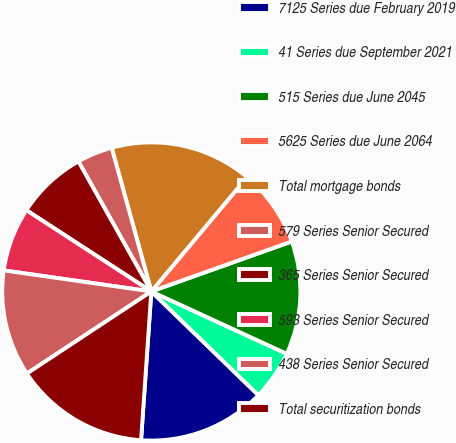Convert chart. <chart><loc_0><loc_0><loc_500><loc_500><pie_chart><fcel>7125 Series due February 2019<fcel>41 Series due September 2021<fcel>515 Series due June 2045<fcel>5625 Series due June 2064<fcel>Total mortgage bonds<fcel>579 Series Senior Secured<fcel>365 Series Senior Secured<fcel>593 Series Senior Secured<fcel>438 Series Senior Secured<fcel>Total securitization bonds<nl><fcel>13.85%<fcel>5.38%<fcel>12.31%<fcel>8.46%<fcel>15.38%<fcel>3.85%<fcel>7.69%<fcel>6.92%<fcel>11.54%<fcel>14.62%<nl></chart> 